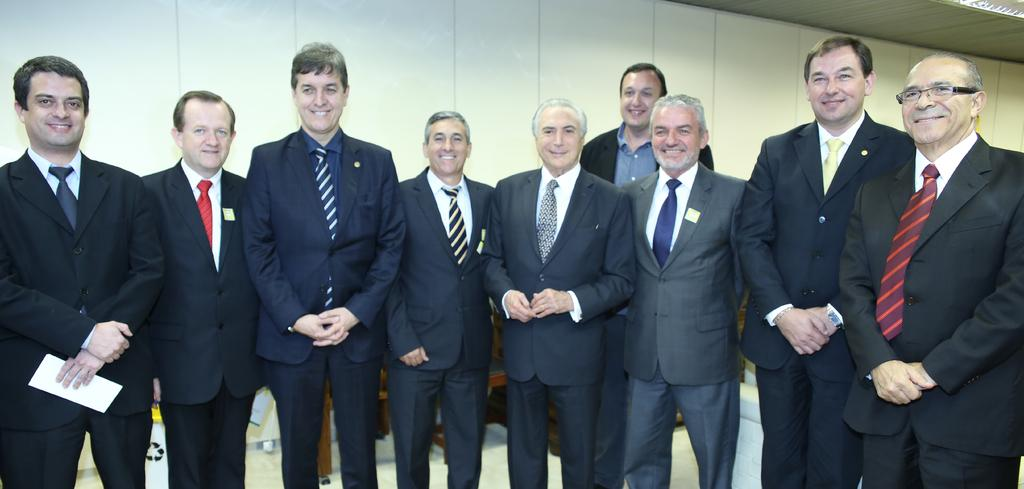What is happening in the image? There is a group of people in the image, and they are standing and smiling. What can be seen in the background of the image? There is a wall and some objects in the background of the image. How many coats can be seen on the people in the image? There is no information about coats in the image, so it cannot be determined how many coats are present. 